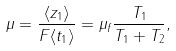Convert formula to latex. <formula><loc_0><loc_0><loc_500><loc_500>\mu = \frac { \langle z _ { 1 } \rangle } { F \langle t _ { 1 } \rangle } = \mu _ { f } \frac { T _ { 1 } } { T _ { 1 } + T _ { 2 } } ,</formula> 